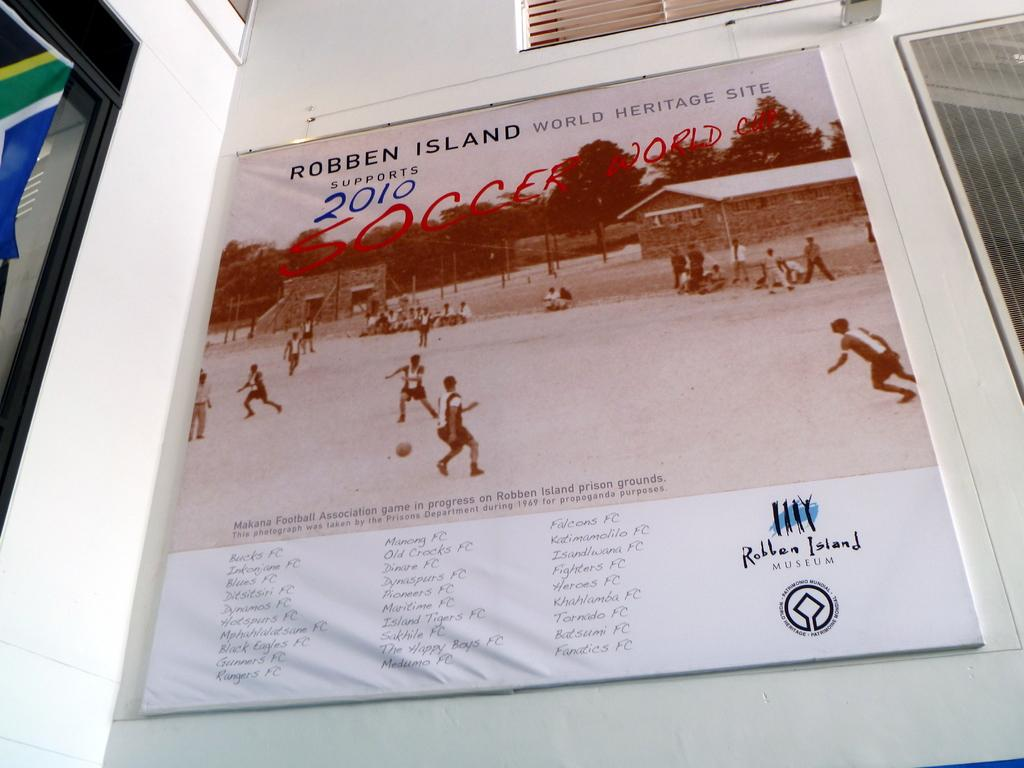<image>
Share a concise interpretation of the image provided. A photo from Robben Island museum reading 2010. 